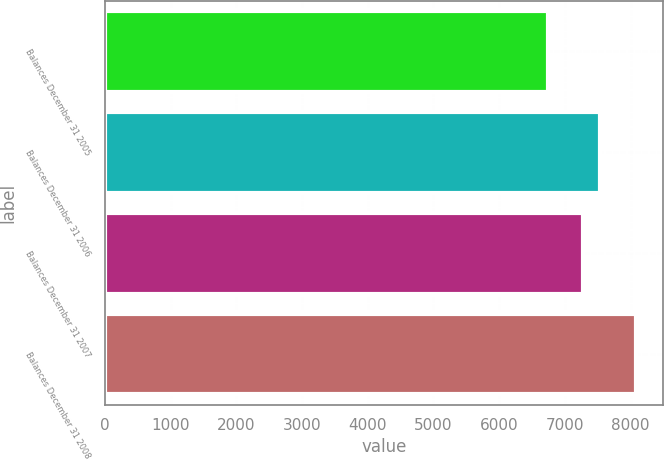<chart> <loc_0><loc_0><loc_500><loc_500><bar_chart><fcel>Balances December 31 2005<fcel>Balances December 31 2006<fcel>Balances December 31 2007<fcel>Balances December 31 2008<nl><fcel>6737<fcel>7539<fcel>7275<fcel>8089<nl></chart> 